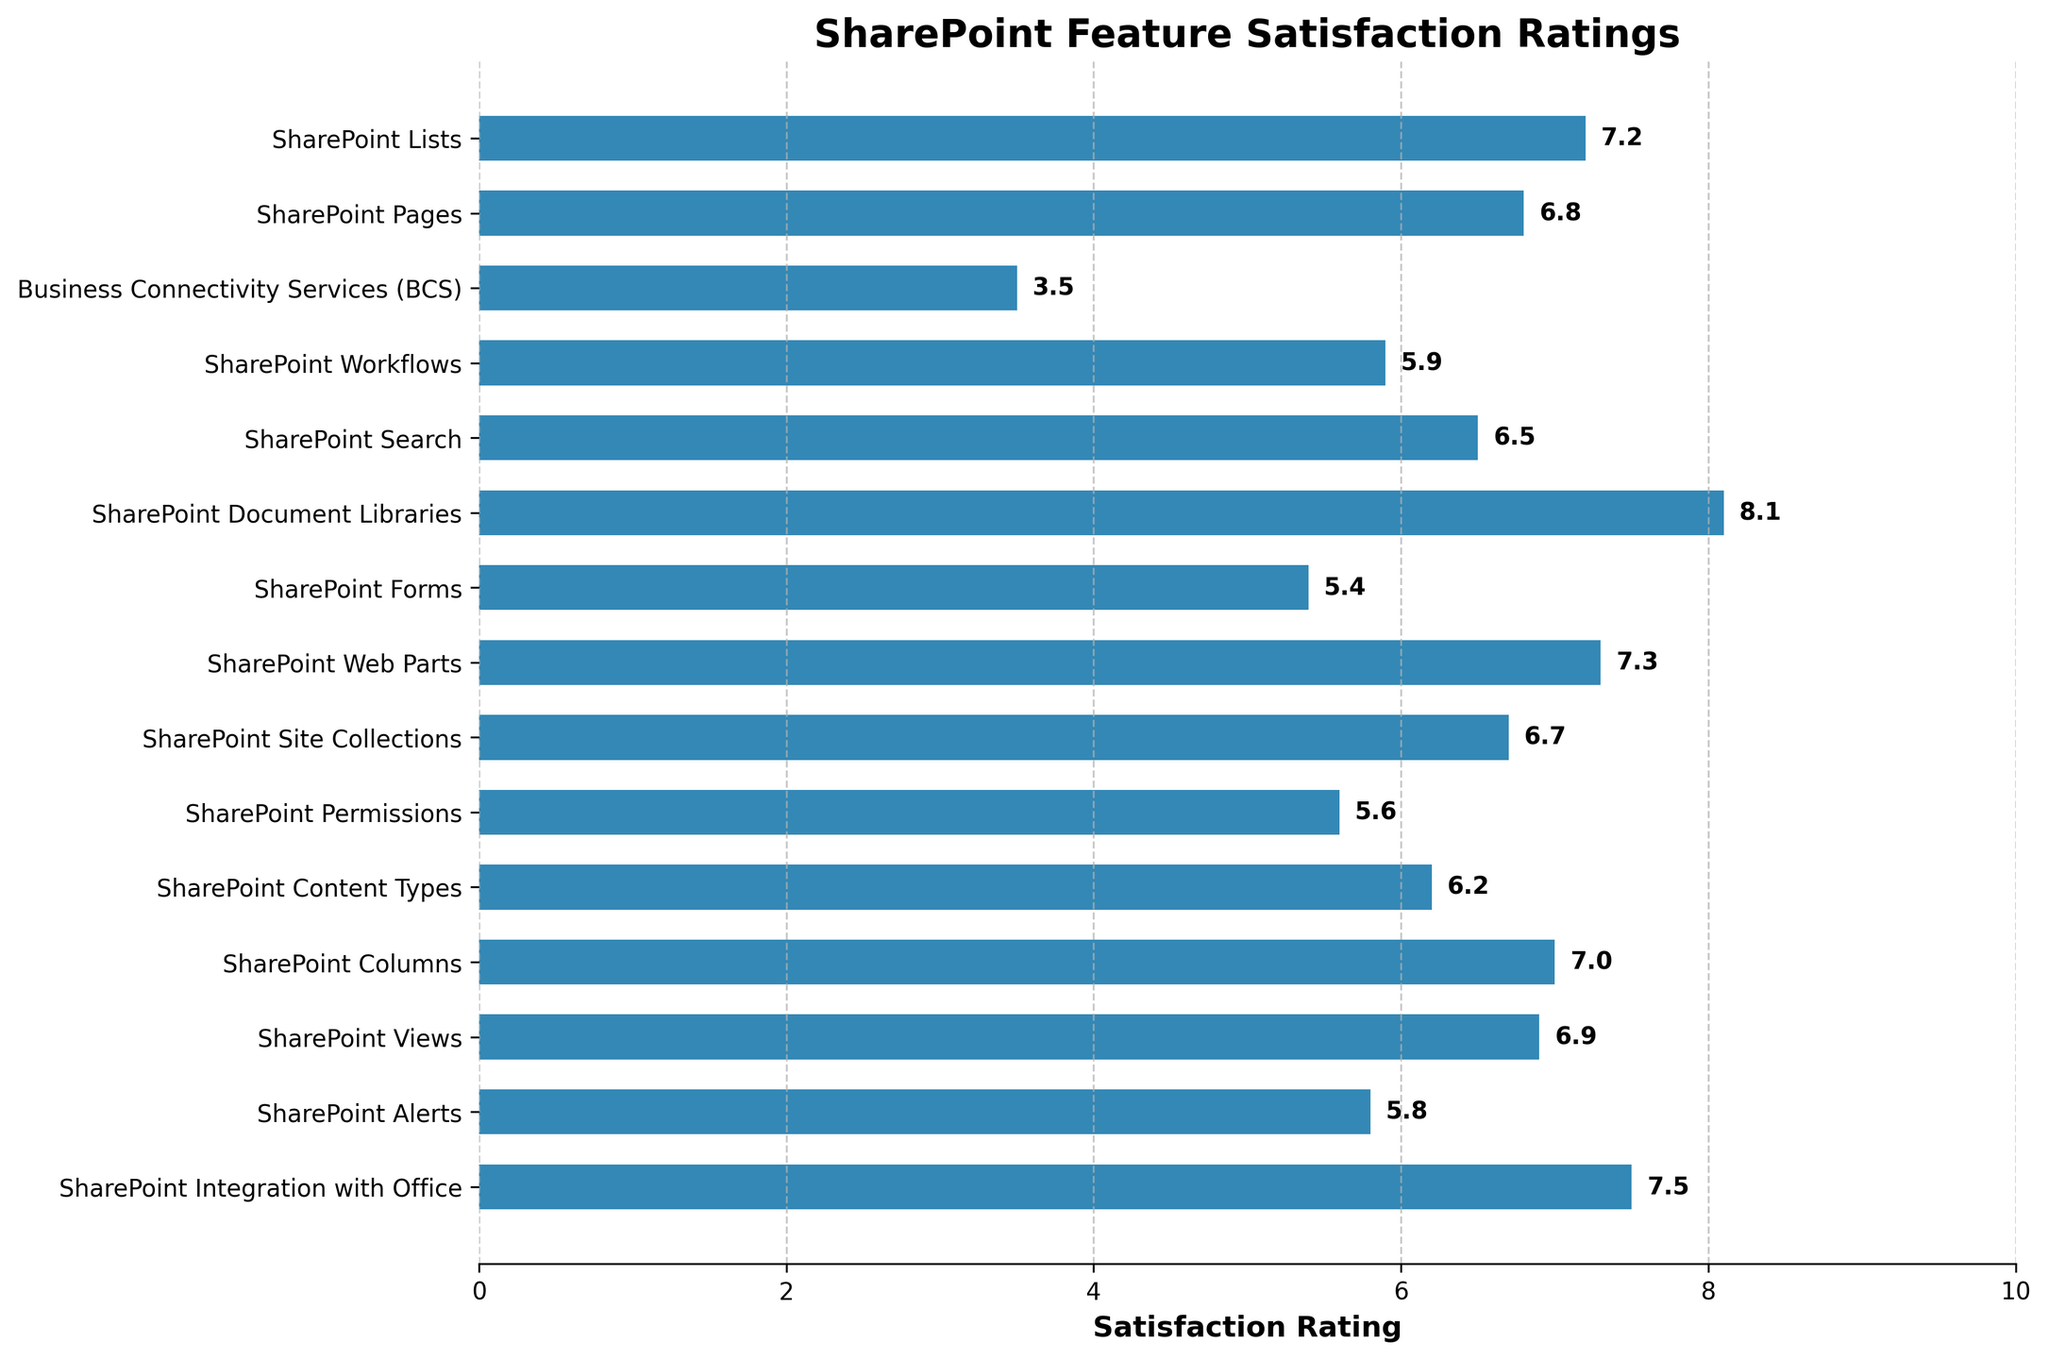Which SharePoint feature has the highest satisfaction rating? By observing the chart, the bar corresponding to SharePoint Document Libraries is the longest, indicating it has the highest satisfaction rating.
Answer: SharePoint Document Libraries Which SharePoint feature has the lowest satisfaction rating? The bar representing Business Connectivity Services (BCS) is the shortest in the chart, indicating the lowest satisfaction rating.
Answer: Business Connectivity Services (BCS) How does the satisfaction rating of SharePoint Lists compare to SharePoint Web Parts? The bar for SharePoint Lists is slightly shorter than the bar for SharePoint Web Parts, indicating that the satisfaction rating for SharePoint Lists is slightly lower than that for SharePoint Web Parts.
Answer: SharePoint Lists is lower What is the difference in satisfaction ratings between SharePoint Integration with Office and SharePoint Workflows? SharePoint Integration with Office has a satisfaction rating of 7.5, while SharePoint Workflows has a satisfaction rating of 5.9. The difference is 7.5 - 5.9 = 1.6.
Answer: 1.6 What's the average satisfaction rating of the features SharePoint Site Collections, SharePoint Permissions, and SharePoint Views? Adding the satisfaction ratings: 6.7 (Site Collections) + 5.6 (Permissions) + 6.9 (Views) = 19.2. Dividing by 3, the average is 19.2 / 3 = 6.4.
Answer: 6.4 Which feature has a satisfaction rating closest to 7.0? The bar for SharePoint Columns is almost at the 7.0 mark, indicating it has a satisfaction rating closest to 7.0.
Answer: SharePoint Columns Is the satisfaction rating for Business Connectivity Services (BCS) greater than or less than half of the rating for SharePoint Document Libraries? The satisfaction rating for Business Connectivity Services (BCS) is 3.5, and half of the rating for SharePoint Document Libraries (8.1) is 4.05. 3.5 is less than 4.05.
Answer: Less than What is the total satisfaction rating for SharePoint Lists, SharePoint Search, and SharePoint Alerts? Adding the satisfaction ratings: 7.2 (Lists) + 6.5 (Search) + 5.8 (Alerts) = 19.5.
Answer: 19.5 